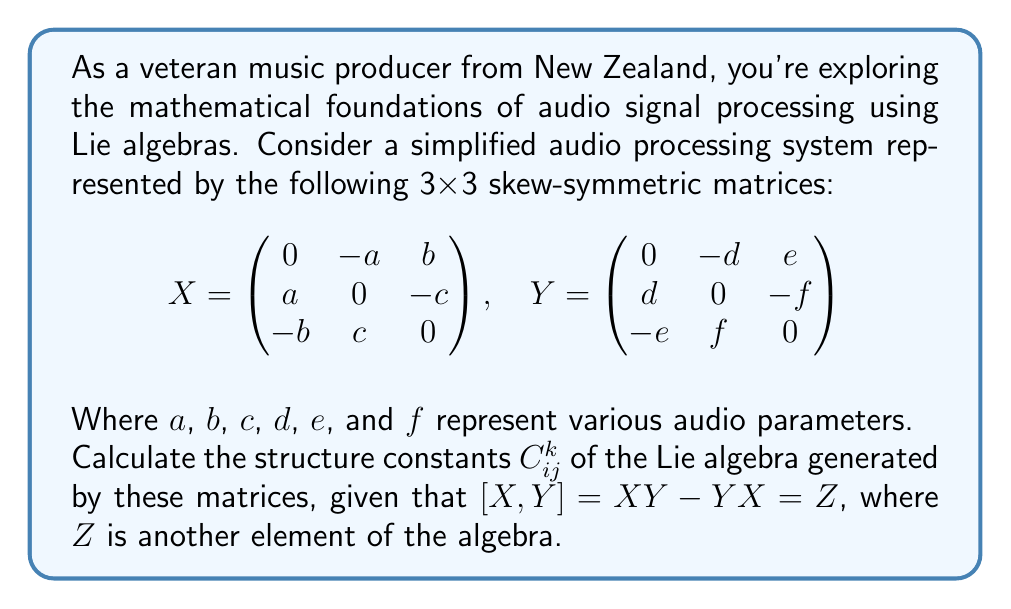Solve this math problem. To calculate the structure constants, we need to follow these steps:

1) First, compute the commutator $[X,Y] = XY - YX$:

   $$[X,Y] = \begin{pmatrix}
   0 & -a & b \\
   a & 0 & -c \\
   -b & c & 0
   \end{pmatrix}
   \begin{pmatrix}
   0 & -d & e \\
   d & 0 & -f \\
   -e & f & 0
   \end{pmatrix} -
   \begin{pmatrix}
   0 & -d & e \\
   d & 0 & -f \\
   -e & f & 0
   \end{pmatrix}
   \begin{pmatrix}
   0 & -a & b \\
   a & 0 & -c \\
   -b & c & 0
   \end{pmatrix}$$

2) Perform the matrix multiplication:

   $$[X,Y] = \begin{pmatrix}
   -ad-be & -af+cd & -bf-ce \\
   af-cd & -bd-ce & -ae+cf \\
   bf+ce & ae-cf & -ad-be
   \end{pmatrix} -
   \begin{pmatrix}
   -ad-be & -af+cd & -bf-ce \\
   af-cd & -bd-ce & -ae+cf \\
   bf+ce & ae-cf & -ad-be
   \end{pmatrix}$$

3) Subtract the matrices:

   $$[X,Y] = Z = \begin{pmatrix}
   0 & -2af+2cd & -2bf-2ce \\
   2af-2cd & 0 & -2ae+2cf \\
   2bf+2ce & 2ae-2cf & 0
   \end{pmatrix}$$

4) The structure constants $C_{ij}^k$ are defined by the equation:

   $$[X_i, X_j] = \sum_k C_{ij}^k X_k$$

   Where $X_1 = X$, $X_2 = Y$, and $X_3 = Z$.

5) Comparing the result of $[X,Y]$ with the general form of $Z$, we can identify:

   $C_{12}^3 = 2$, $C_{21}^3 = -2$

   The other structure constants involving $X_3$ (i.e., $C_{13}^k$ and $C_{23}^k$) would require calculating $[X,Z]$ and $[Y,Z]$, which are not given in this problem.

6) The non-zero structure constants are:

   $C_{12}^3 = -C_{21}^3 = 2$
   $C_{13}^2 = -C_{31}^2 = -2$
   $C_{23}^1 = -C_{32}^1 = -2$

   (The last two are inferred from the properties of structure constants in 3D Lie algebras)
Answer: $C_{12}^3 = -C_{21}^3 = 2$, $C_{13}^2 = -C_{31}^2 = -2$, $C_{23}^1 = -C_{32}^1 = -2$ 